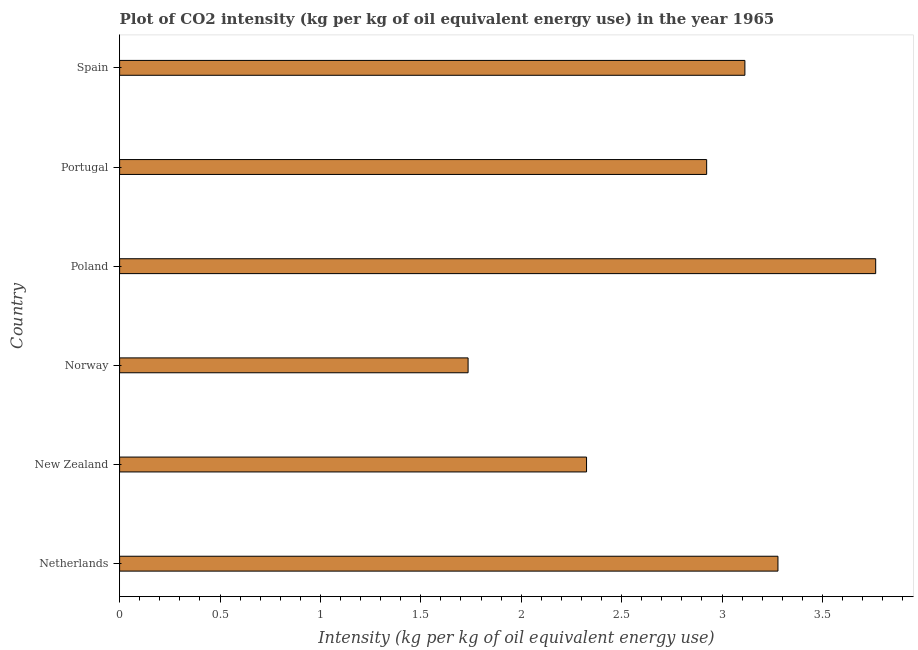Does the graph contain any zero values?
Your response must be concise. No. What is the title of the graph?
Offer a very short reply. Plot of CO2 intensity (kg per kg of oil equivalent energy use) in the year 1965. What is the label or title of the X-axis?
Your answer should be compact. Intensity (kg per kg of oil equivalent energy use). What is the co2 intensity in Portugal?
Ensure brevity in your answer.  2.92. Across all countries, what is the maximum co2 intensity?
Give a very brief answer. 3.77. Across all countries, what is the minimum co2 intensity?
Offer a terse response. 1.74. In which country was the co2 intensity minimum?
Your answer should be compact. Norway. What is the sum of the co2 intensity?
Your answer should be compact. 17.14. What is the difference between the co2 intensity in New Zealand and Norway?
Your response must be concise. 0.59. What is the average co2 intensity per country?
Your answer should be very brief. 2.86. What is the median co2 intensity?
Your answer should be very brief. 3.02. What is the ratio of the co2 intensity in New Zealand to that in Spain?
Provide a short and direct response. 0.75. Is the co2 intensity in Poland less than that in Portugal?
Give a very brief answer. No. What is the difference between the highest and the second highest co2 intensity?
Offer a terse response. 0.49. Is the sum of the co2 intensity in Norway and Poland greater than the maximum co2 intensity across all countries?
Provide a short and direct response. Yes. What is the difference between the highest and the lowest co2 intensity?
Ensure brevity in your answer.  2.03. In how many countries, is the co2 intensity greater than the average co2 intensity taken over all countries?
Your answer should be very brief. 4. How many countries are there in the graph?
Your answer should be very brief. 6. Are the values on the major ticks of X-axis written in scientific E-notation?
Offer a very short reply. No. What is the Intensity (kg per kg of oil equivalent energy use) in Netherlands?
Your answer should be very brief. 3.28. What is the Intensity (kg per kg of oil equivalent energy use) in New Zealand?
Your response must be concise. 2.33. What is the Intensity (kg per kg of oil equivalent energy use) in Norway?
Your answer should be compact. 1.74. What is the Intensity (kg per kg of oil equivalent energy use) in Poland?
Your answer should be compact. 3.77. What is the Intensity (kg per kg of oil equivalent energy use) of Portugal?
Keep it short and to the point. 2.92. What is the Intensity (kg per kg of oil equivalent energy use) in Spain?
Offer a very short reply. 3.11. What is the difference between the Intensity (kg per kg of oil equivalent energy use) in Netherlands and New Zealand?
Your response must be concise. 0.95. What is the difference between the Intensity (kg per kg of oil equivalent energy use) in Netherlands and Norway?
Give a very brief answer. 1.54. What is the difference between the Intensity (kg per kg of oil equivalent energy use) in Netherlands and Poland?
Provide a succinct answer. -0.49. What is the difference between the Intensity (kg per kg of oil equivalent energy use) in Netherlands and Portugal?
Keep it short and to the point. 0.36. What is the difference between the Intensity (kg per kg of oil equivalent energy use) in Netherlands and Spain?
Make the answer very short. 0.16. What is the difference between the Intensity (kg per kg of oil equivalent energy use) in New Zealand and Norway?
Your answer should be very brief. 0.59. What is the difference between the Intensity (kg per kg of oil equivalent energy use) in New Zealand and Poland?
Make the answer very short. -1.44. What is the difference between the Intensity (kg per kg of oil equivalent energy use) in New Zealand and Portugal?
Offer a terse response. -0.6. What is the difference between the Intensity (kg per kg of oil equivalent energy use) in New Zealand and Spain?
Make the answer very short. -0.79. What is the difference between the Intensity (kg per kg of oil equivalent energy use) in Norway and Poland?
Keep it short and to the point. -2.03. What is the difference between the Intensity (kg per kg of oil equivalent energy use) in Norway and Portugal?
Provide a short and direct response. -1.19. What is the difference between the Intensity (kg per kg of oil equivalent energy use) in Norway and Spain?
Give a very brief answer. -1.38. What is the difference between the Intensity (kg per kg of oil equivalent energy use) in Poland and Portugal?
Keep it short and to the point. 0.84. What is the difference between the Intensity (kg per kg of oil equivalent energy use) in Poland and Spain?
Offer a terse response. 0.65. What is the difference between the Intensity (kg per kg of oil equivalent energy use) in Portugal and Spain?
Give a very brief answer. -0.19. What is the ratio of the Intensity (kg per kg of oil equivalent energy use) in Netherlands to that in New Zealand?
Your response must be concise. 1.41. What is the ratio of the Intensity (kg per kg of oil equivalent energy use) in Netherlands to that in Norway?
Offer a very short reply. 1.89. What is the ratio of the Intensity (kg per kg of oil equivalent energy use) in Netherlands to that in Poland?
Ensure brevity in your answer.  0.87. What is the ratio of the Intensity (kg per kg of oil equivalent energy use) in Netherlands to that in Portugal?
Offer a very short reply. 1.12. What is the ratio of the Intensity (kg per kg of oil equivalent energy use) in Netherlands to that in Spain?
Provide a succinct answer. 1.05. What is the ratio of the Intensity (kg per kg of oil equivalent energy use) in New Zealand to that in Norway?
Your answer should be very brief. 1.34. What is the ratio of the Intensity (kg per kg of oil equivalent energy use) in New Zealand to that in Poland?
Offer a terse response. 0.62. What is the ratio of the Intensity (kg per kg of oil equivalent energy use) in New Zealand to that in Portugal?
Give a very brief answer. 0.8. What is the ratio of the Intensity (kg per kg of oil equivalent energy use) in New Zealand to that in Spain?
Your answer should be very brief. 0.75. What is the ratio of the Intensity (kg per kg of oil equivalent energy use) in Norway to that in Poland?
Give a very brief answer. 0.46. What is the ratio of the Intensity (kg per kg of oil equivalent energy use) in Norway to that in Portugal?
Provide a succinct answer. 0.59. What is the ratio of the Intensity (kg per kg of oil equivalent energy use) in Norway to that in Spain?
Make the answer very short. 0.56. What is the ratio of the Intensity (kg per kg of oil equivalent energy use) in Poland to that in Portugal?
Make the answer very short. 1.29. What is the ratio of the Intensity (kg per kg of oil equivalent energy use) in Poland to that in Spain?
Provide a succinct answer. 1.21. What is the ratio of the Intensity (kg per kg of oil equivalent energy use) in Portugal to that in Spain?
Your response must be concise. 0.94. 